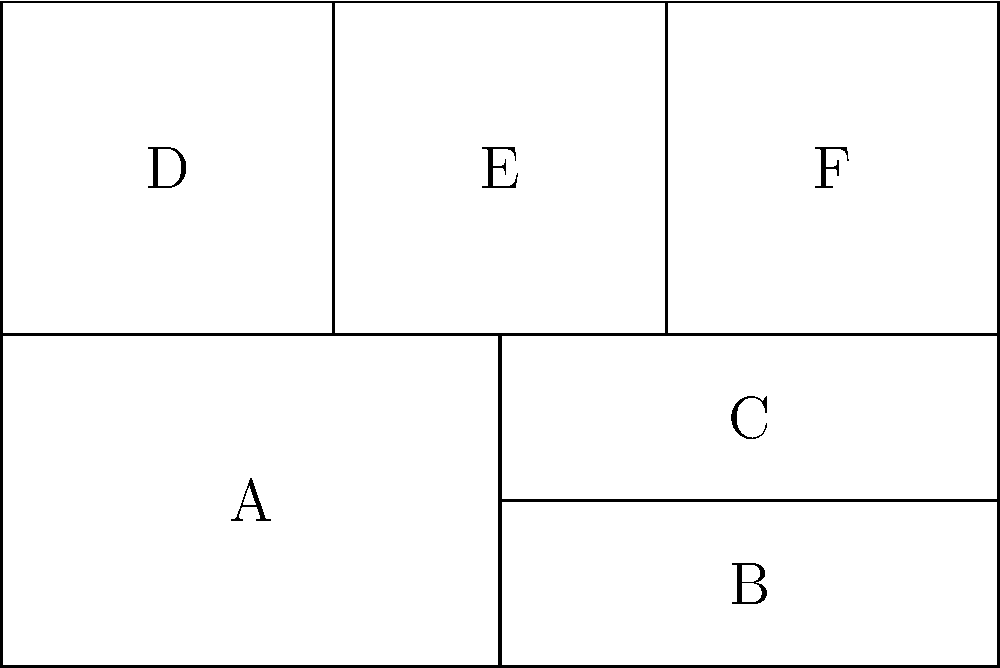In the context of comic book storytelling, how does the panel layout shown above potentially impact the pacing and narrative flow of a graphic novel adaptation? To answer this question, we need to analyze the panel layout and its potential effects on storytelling:

1. Overall structure: The layout consists of six panels arranged in an asymmetrical pattern.

2. Panel sizes:
   - Panel A is the largest, occupying half of the bottom row.
   - Panels B and C are equal in size but smaller than A.
   - Panels D, E, and F are equal in size and form the top row.

3. Reading order: The typical Western reading order (left to right, top to bottom) would suggest a sequence of D-E-F-A-B-C.

4. Pacing implications:
   - The larger Panel A may indicate a more important or impactful moment, potentially slowing down the pacing.
   - The smaller, equal-sized panels (B-C and D-E-F) could suggest a quicker sequence of events or parallel actions.

5. Narrative flow:
   - The asymmetry between the top and bottom rows could create a visual tension or contrast between different story elements.
   - The transition from the three equal panels (D-E-F) to the varied sizes below might indicate a shift in narrative focus or tempo.

6. Adaptation considerations:
   - This layout could be used to emphasize certain scenes or moments from the original graphic novel.
   - It allows for a mix of detailed (larger panels) and rapid (smaller panels) storytelling, which could be useful in adapting complex source material.

In conclusion, this panel layout potentially impacts the pacing and narrative flow by creating a dynamic visual rhythm, emphasizing certain story elements through panel size variation, and allowing for a mix of detailed and rapid storytelling techniques.
Answer: Dynamic pacing through size variation and asymmetry 